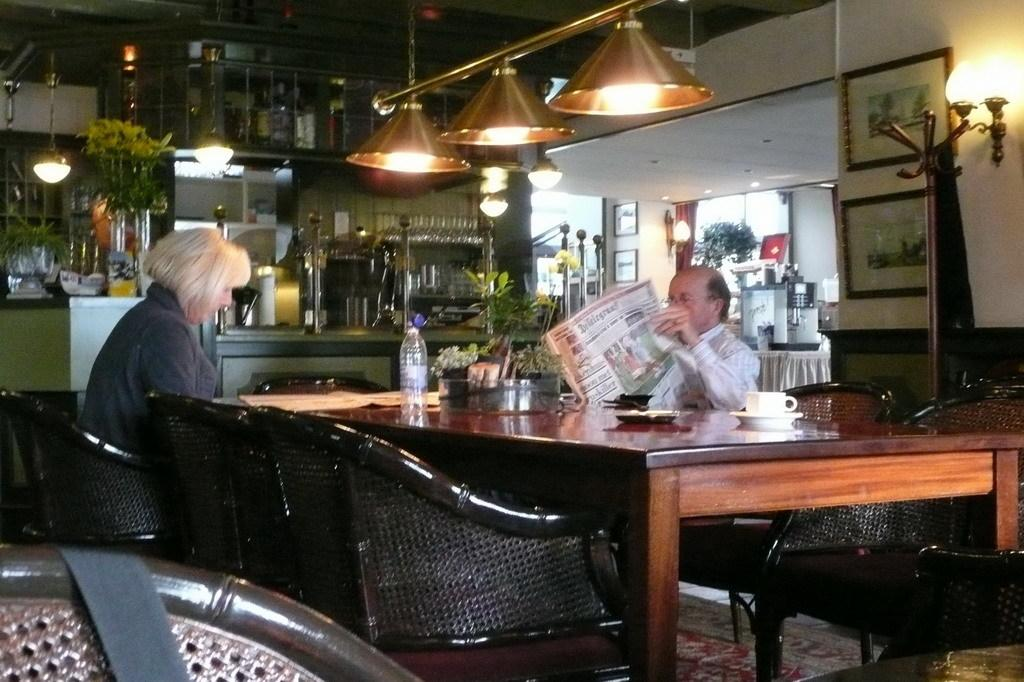What is the woman doing in the image? The woman is sitting in a chair on the left side of the image. What can be seen at the top of the image? There are lights visible at the top of the image. What is the man on the right side of the image doing? The man is reading a newspaper. What type of credit can be seen on the roof in the image? There is no roof or credit present in the image. What kind of beetle can be seen crawling on the newspaper in the image? There are no beetles present in the image; the man is reading a newspaper. 